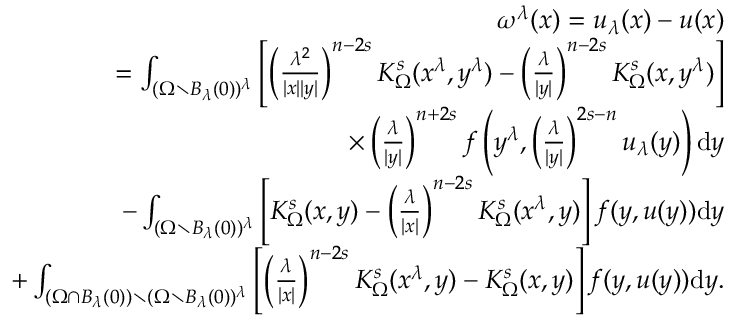Convert formula to latex. <formula><loc_0><loc_0><loc_500><loc_500>\begin{array} { r l r } & { \quad \omega ^ { \lambda } ( x ) = u _ { \lambda } ( x ) - u ( x ) } \\ & { = \int _ { ( \Omega \ B _ { \lambda } ( 0 ) ) ^ { \lambda } } \left [ \left ( \frac { \lambda ^ { 2 } } { | x | | y | } \right ) ^ { n - 2 s } K _ { \Omega } ^ { s } ( x ^ { \lambda } , y ^ { \lambda } ) - \left ( \frac { \lambda } { | y | } \right ) ^ { n - 2 s } K _ { \Omega } ^ { s } ( x , y ^ { \lambda } ) \right ] } \\ & { \quad \times \left ( \frac { \lambda } { | y | } \right ) ^ { n + 2 s } f \left ( y ^ { \lambda } , \left ( \frac { \lambda } { | y | } \right ) ^ { 2 s - n } u _ { \lambda } ( y ) \right ) \mathrm d y } \\ & { \quad - \int _ { ( \Omega \ B _ { \lambda } ( 0 ) ) ^ { \lambda } } \left [ K _ { \Omega } ^ { s } ( x , y ) - \left ( \frac { \lambda } { | x | } \right ) ^ { n - 2 s } K _ { \Omega } ^ { s } ( x ^ { \lambda } , y ) \right ] f ( y , u ( y ) ) \mathrm d y } \\ & { \quad + \int _ { ( \Omega \cap B _ { \lambda } ( 0 ) ) \ ( \Omega \ B _ { \lambda } ( 0 ) ) ^ { \lambda } } \left [ \left ( \frac { \lambda } { | x | } \right ) ^ { n - 2 s } K _ { \Omega } ^ { s } ( x ^ { \lambda } , y ) - K _ { \Omega } ^ { s } ( x , y ) \right ] f ( y , u ( y ) ) \mathrm d y . } \end{array}</formula> 